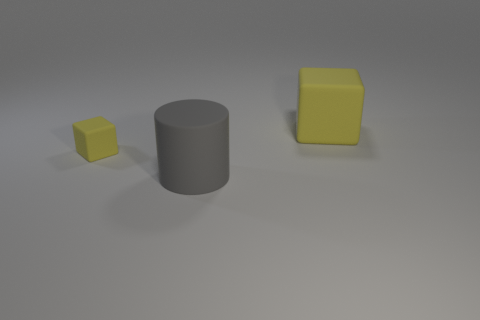Does the tiny object have the same color as the big cube?
Offer a terse response. Yes. There is a tiny rubber cube; is it the same color as the rubber block to the right of the gray thing?
Offer a very short reply. Yes. There is a large thing that is the same color as the small matte object; what is its shape?
Your response must be concise. Cube. What is the size of the rubber cube that is the same color as the small rubber object?
Provide a succinct answer. Large. What number of other objects are the same shape as the gray matte thing?
Your response must be concise. 0. There is a small yellow cube; are there any big objects on the right side of it?
Your response must be concise. Yes. Is the size of the gray thing the same as the yellow cube that is to the left of the large yellow rubber thing?
Give a very brief answer. No. There is another matte object that is the same shape as the small object; what is its size?
Your response must be concise. Large. There is a block that is right of the gray thing; is it the same size as the rubber object that is in front of the tiny yellow rubber thing?
Your response must be concise. Yes. How many large things are either yellow rubber cubes or gray objects?
Ensure brevity in your answer.  2. 